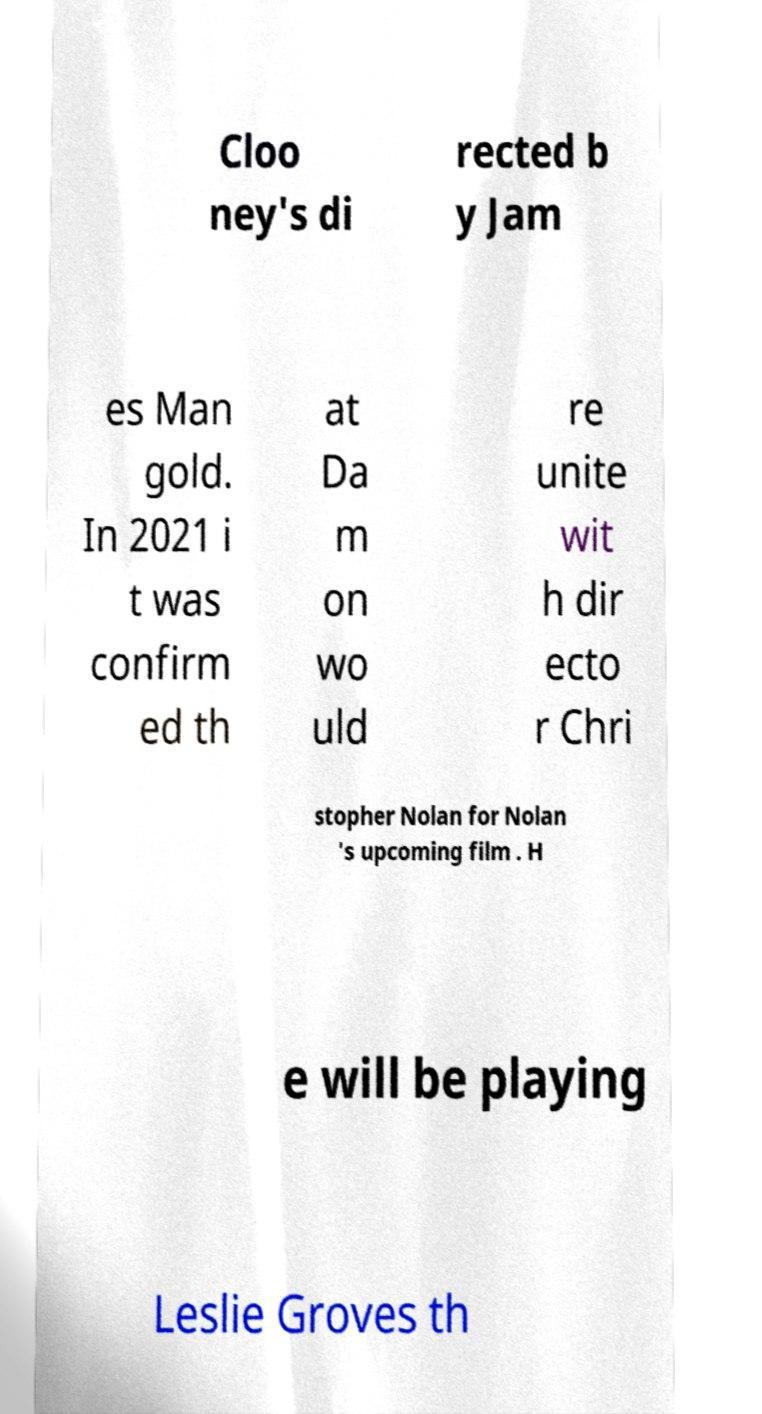Please identify and transcribe the text found in this image. Cloo ney's di rected b y Jam es Man gold. In 2021 i t was confirm ed th at Da m on wo uld re unite wit h dir ecto r Chri stopher Nolan for Nolan 's upcoming film . H e will be playing Leslie Groves th 